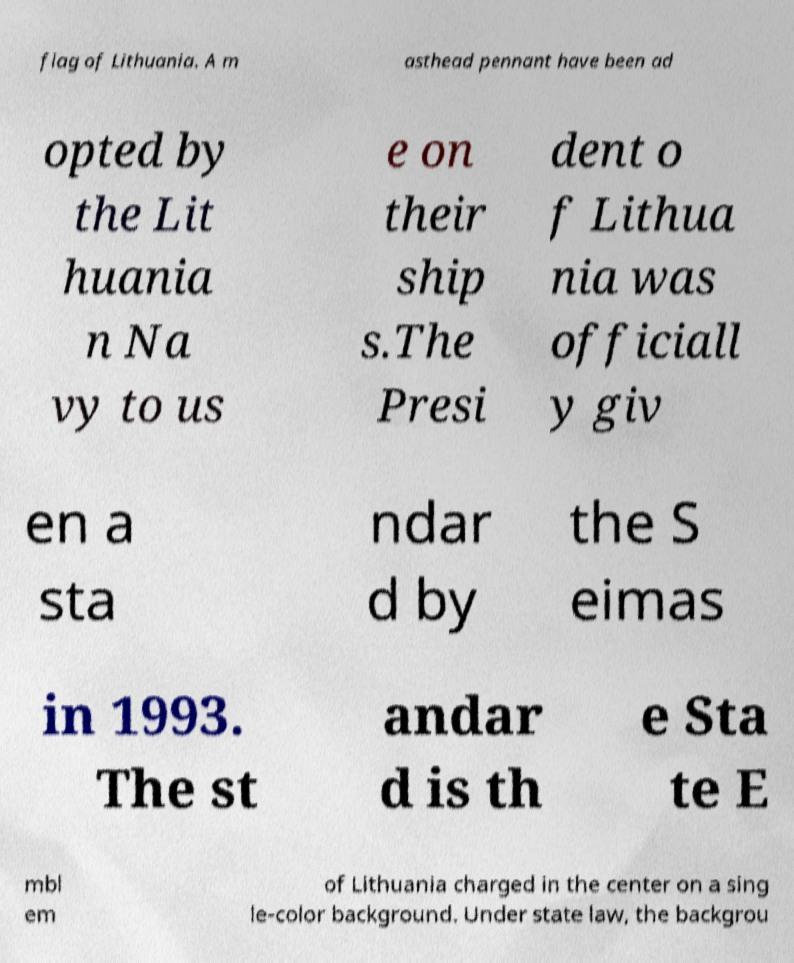Could you assist in decoding the text presented in this image and type it out clearly? flag of Lithuania. A m asthead pennant have been ad opted by the Lit huania n Na vy to us e on their ship s.The Presi dent o f Lithua nia was officiall y giv en a sta ndar d by the S eimas in 1993. The st andar d is th e Sta te E mbl em of Lithuania charged in the center on a sing le-color background. Under state law, the backgrou 